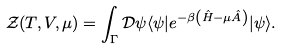Convert formula to latex. <formula><loc_0><loc_0><loc_500><loc_500>\mathcal { Z } ( T , V , \mu ) = \int _ { \Gamma } \mathcal { D } \psi \langle \psi | e ^ { - \beta \left ( \hat { H } - \mu \hat { A } \right ) } | \psi \rangle .</formula> 